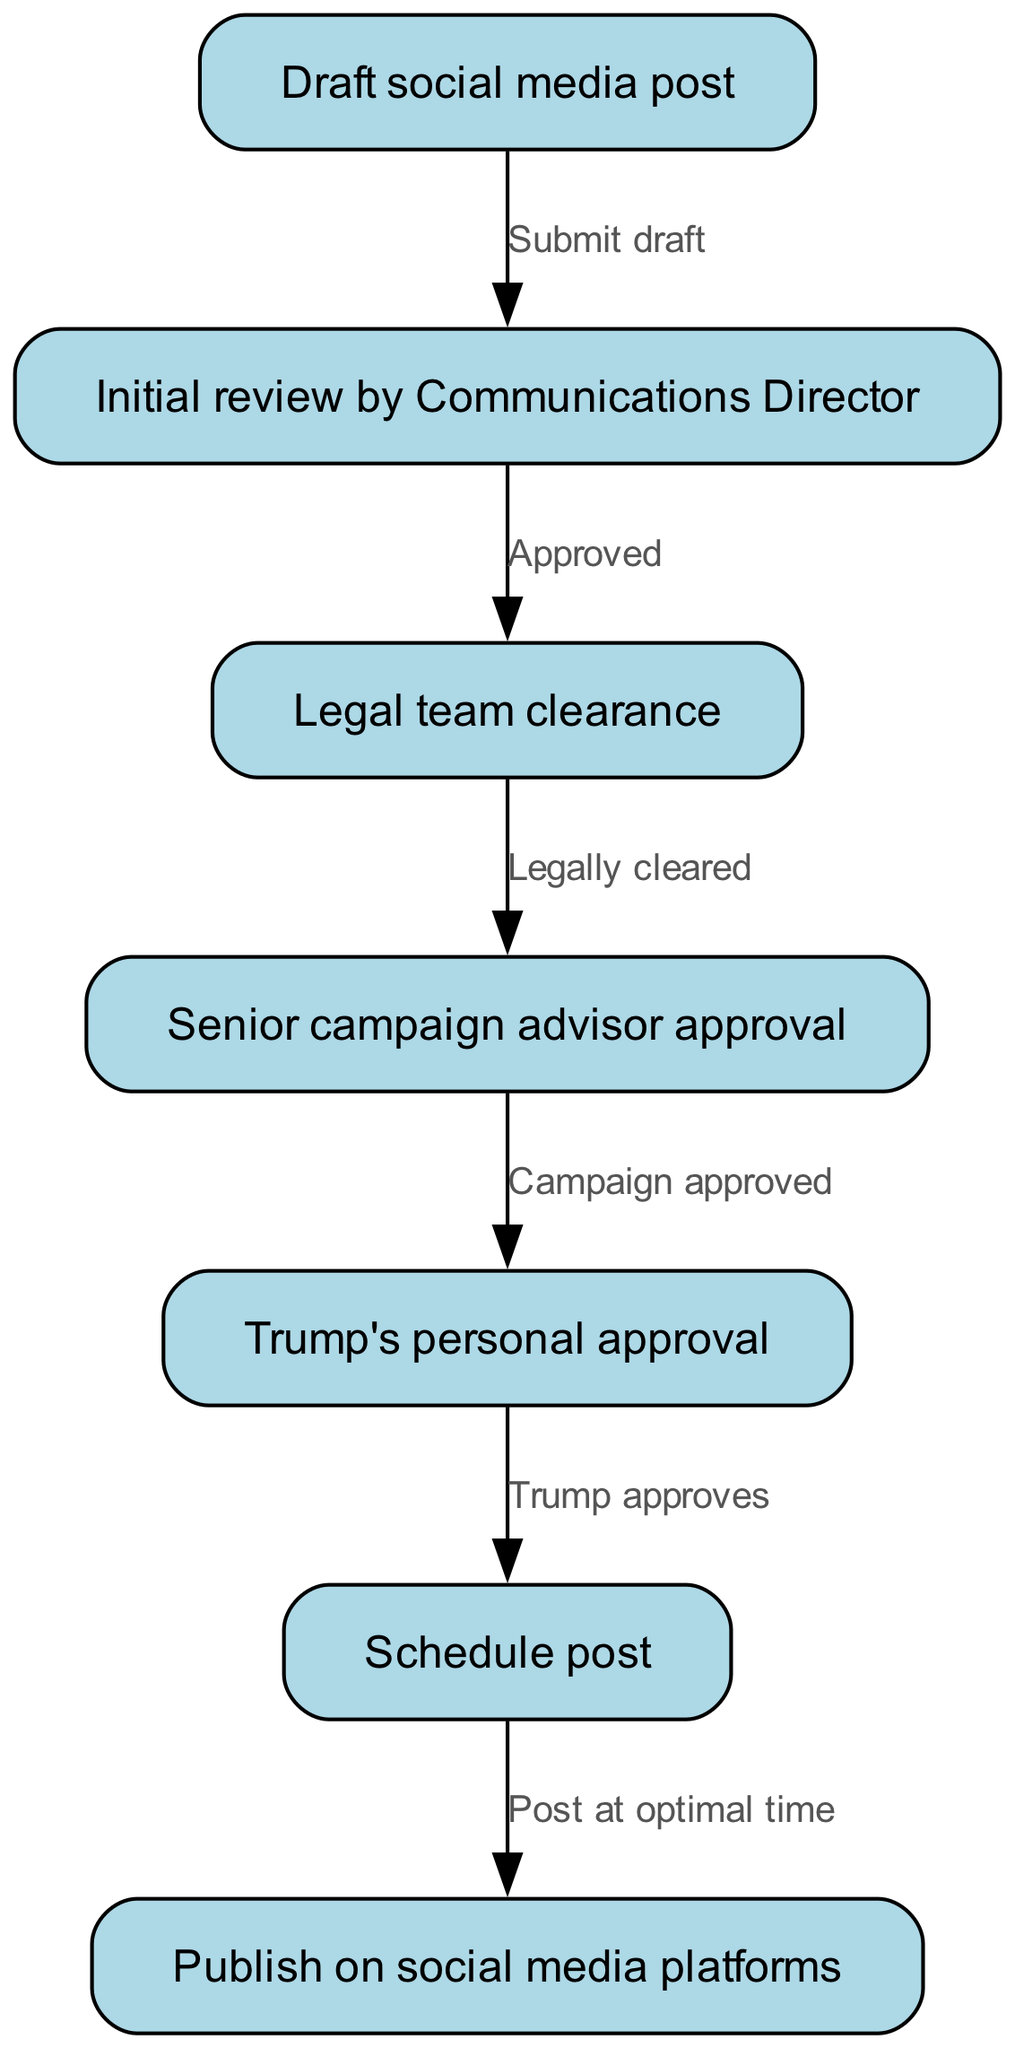What's the first node in the workflow? The first node in the workflow is where the process begins, which is labeled "Draft social media post." It sets the stage for the entire approval workflow.
Answer: Draft social media post How many nodes are present in the diagram? By counting each node listed in the provided data, there are six distinct nodes in the social media content approval workflow.
Answer: Six What is the outcome of an initial review? The outcome of the initial review by the Communications Director leads to the next step if approved. The text on the edge indicates the relationship between "Initial review by Communications Director" and "Legal team clearance."
Answer: Approved Which node requires Trump's personal approval? In the flowchart, after the senior campaign advisor approval node, the process moves to the node labeled "Trump's personal approval," which means this step is necessary before scheduling.
Answer: Trump's personal approval What happens after Trump's approval? Following Trump's personal approval, the workflow moves to the next stage, which is scheduling the post. The edge text describes the action taken after receiving Trump's approval.
Answer: Schedule post What is the last step of the workflow? The final step of the workflow, representing the completion of the process, is publishing the social media post on platforms. It indicates the end point of the approval flow.
Answer: Publish on social media platforms If the legal team does not clear the post, what is the outcome? If the legal team does not clear the post, it would not proceed to the next node ("Senior campaign advisor approval"). The process requires legal clearance as a prerequisite to continue.
Answer: Not approved What links the review by the senior campaign advisor to Trump's approval? The connection between the senior campaign advisor approval and Trump's approval is through the phrase "Campaign approved," which indicates that approval from the senior campaign advisor is necessary to move forward to Trump's personal approval.
Answer: Campaign approved How does the workflow start? The workflow initiates with the action of submitting a draft social media post, which is the first step in the approval process. This action is crucial for progressing to subsequent reviews.
Answer: Submit draft 